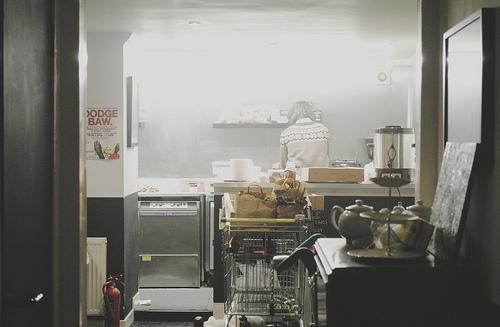How many people are there?
Give a very brief answer. 1. 